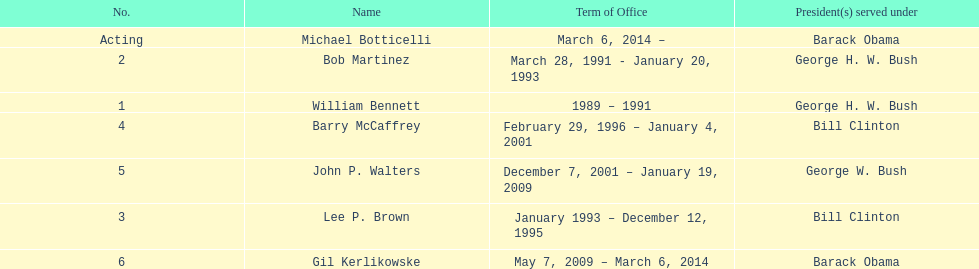Who serves inder barack obama? Gil Kerlikowske. 